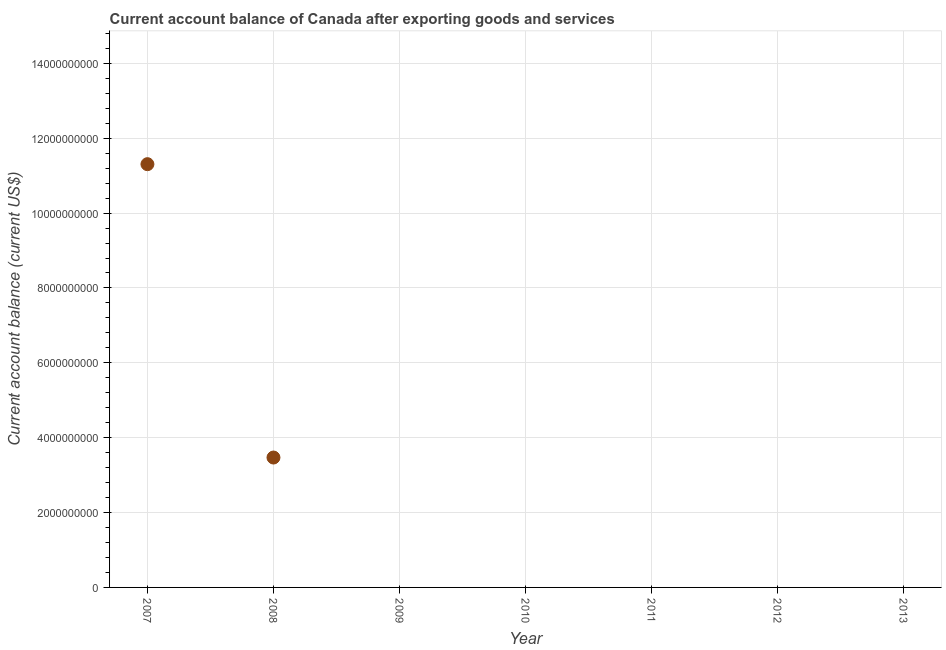What is the current account balance in 2010?
Your answer should be very brief. 0. Across all years, what is the maximum current account balance?
Offer a terse response. 1.13e+1. In which year was the current account balance maximum?
Provide a succinct answer. 2007. What is the sum of the current account balance?
Provide a short and direct response. 1.48e+1. What is the average current account balance per year?
Provide a succinct answer. 2.11e+09. What is the median current account balance?
Provide a succinct answer. 0. What is the ratio of the current account balance in 2007 to that in 2008?
Make the answer very short. 3.26. What is the difference between the highest and the lowest current account balance?
Your answer should be very brief. 1.13e+1. Does the current account balance monotonically increase over the years?
Provide a short and direct response. No. How many years are there in the graph?
Provide a short and direct response. 7. What is the difference between two consecutive major ticks on the Y-axis?
Provide a short and direct response. 2.00e+09. Are the values on the major ticks of Y-axis written in scientific E-notation?
Provide a succinct answer. No. What is the title of the graph?
Provide a succinct answer. Current account balance of Canada after exporting goods and services. What is the label or title of the Y-axis?
Make the answer very short. Current account balance (current US$). What is the Current account balance (current US$) in 2007?
Provide a short and direct response. 1.13e+1. What is the Current account balance (current US$) in 2008?
Offer a very short reply. 3.47e+09. What is the Current account balance (current US$) in 2012?
Your response must be concise. 0. What is the Current account balance (current US$) in 2013?
Give a very brief answer. 0. What is the difference between the Current account balance (current US$) in 2007 and 2008?
Your answer should be very brief. 7.84e+09. What is the ratio of the Current account balance (current US$) in 2007 to that in 2008?
Give a very brief answer. 3.26. 